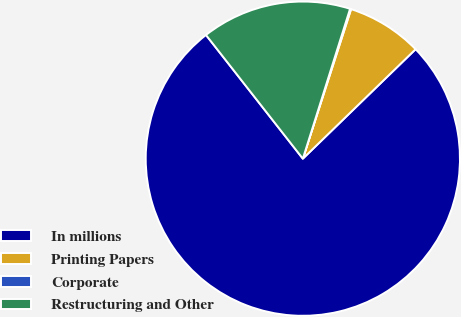<chart> <loc_0><loc_0><loc_500><loc_500><pie_chart><fcel>In millions<fcel>Printing Papers<fcel>Corporate<fcel>Restructuring and Other<nl><fcel>76.69%<fcel>7.77%<fcel>0.11%<fcel>15.43%<nl></chart> 